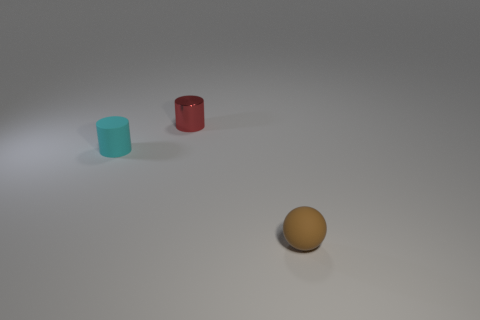Is there anything else that is the same material as the brown ball?
Keep it short and to the point. Yes. Is the number of red metal objects behind the shiny object the same as the number of tiny green matte cylinders?
Keep it short and to the point. Yes. There is a thing that is to the right of the object that is behind the small rubber cylinder; what is it made of?
Ensure brevity in your answer.  Rubber. What is the shape of the red shiny object?
Your answer should be very brief. Cylinder. Is the number of shiny cylinders that are to the left of the small cyan matte object the same as the number of cyan objects in front of the brown object?
Offer a terse response. Yes. Is the number of matte things that are on the left side of the tiny red thing greater than the number of small cyan metal blocks?
Your response must be concise. Yes. There is another object that is made of the same material as the tiny cyan thing; what shape is it?
Your answer should be compact. Sphere. There is a tiny matte thing that is in front of the small matte thing that is behind the brown thing; what shape is it?
Provide a succinct answer. Sphere. There is a metallic thing that is behind the small rubber object to the left of the brown rubber thing; what size is it?
Your response must be concise. Small. What color is the tiny thing in front of the cyan rubber cylinder?
Ensure brevity in your answer.  Brown. 